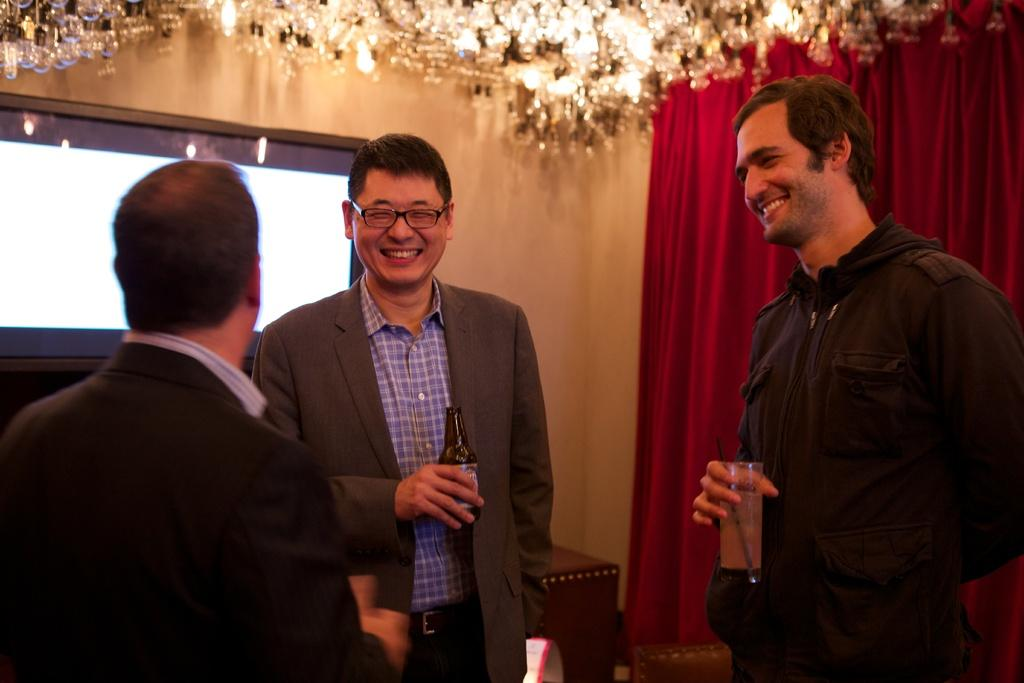How many people are in the image? There are three people in the image. What are the people doing in the image? The people are standing in the image. What are the people wearing? The people are wearing different color dresses. What are the people holding in the image? The people are holding something. What can be seen in the background of the image? There are red curtains and a screen in the background. What color is the wall in the image? The wall is cream-colored. What type of juice is being served in the image? There is no juice present in the image. What color is the coat worn by the person on the left? There is no coat visible in the image, as the people are wearing dresses. 